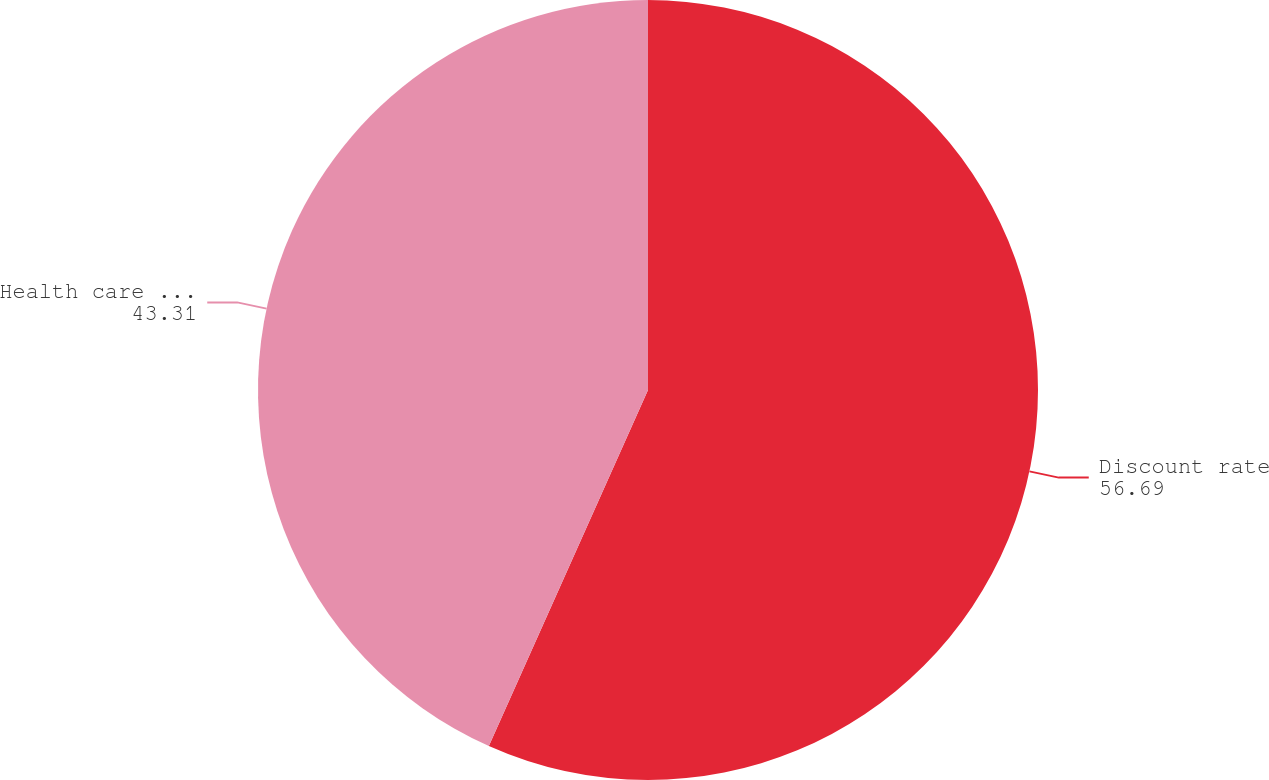Convert chart to OTSL. <chart><loc_0><loc_0><loc_500><loc_500><pie_chart><fcel>Discount rate<fcel>Health care cost trend<nl><fcel>56.69%<fcel>43.31%<nl></chart> 